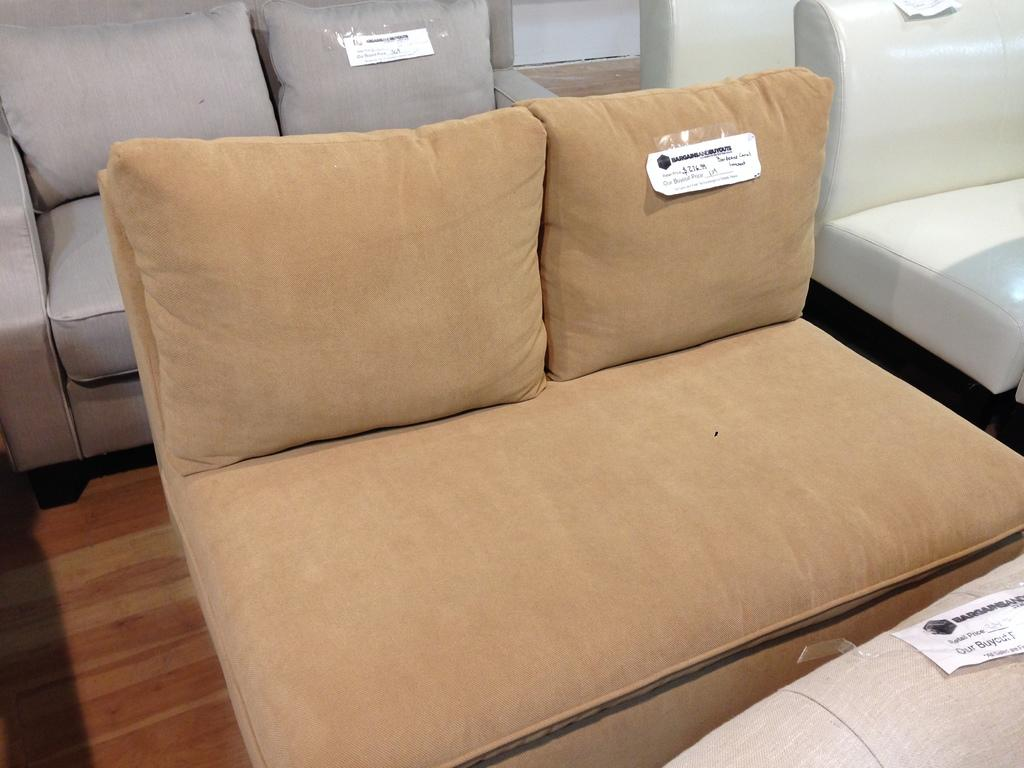What type of furniture is present in the image? There are different colored sofas in the image. Where are the sofas located? The sofas are on the floor. What color is the floor in the image? The floor is brown in color. What can be seen in the background of the image? There is a white-colored wall in the background of the image. What type of caption is written on the page in the image? There is no page or caption present in the image; it only features different colored sofas on the floor with a brown floor and a white-colored wall in the background. 